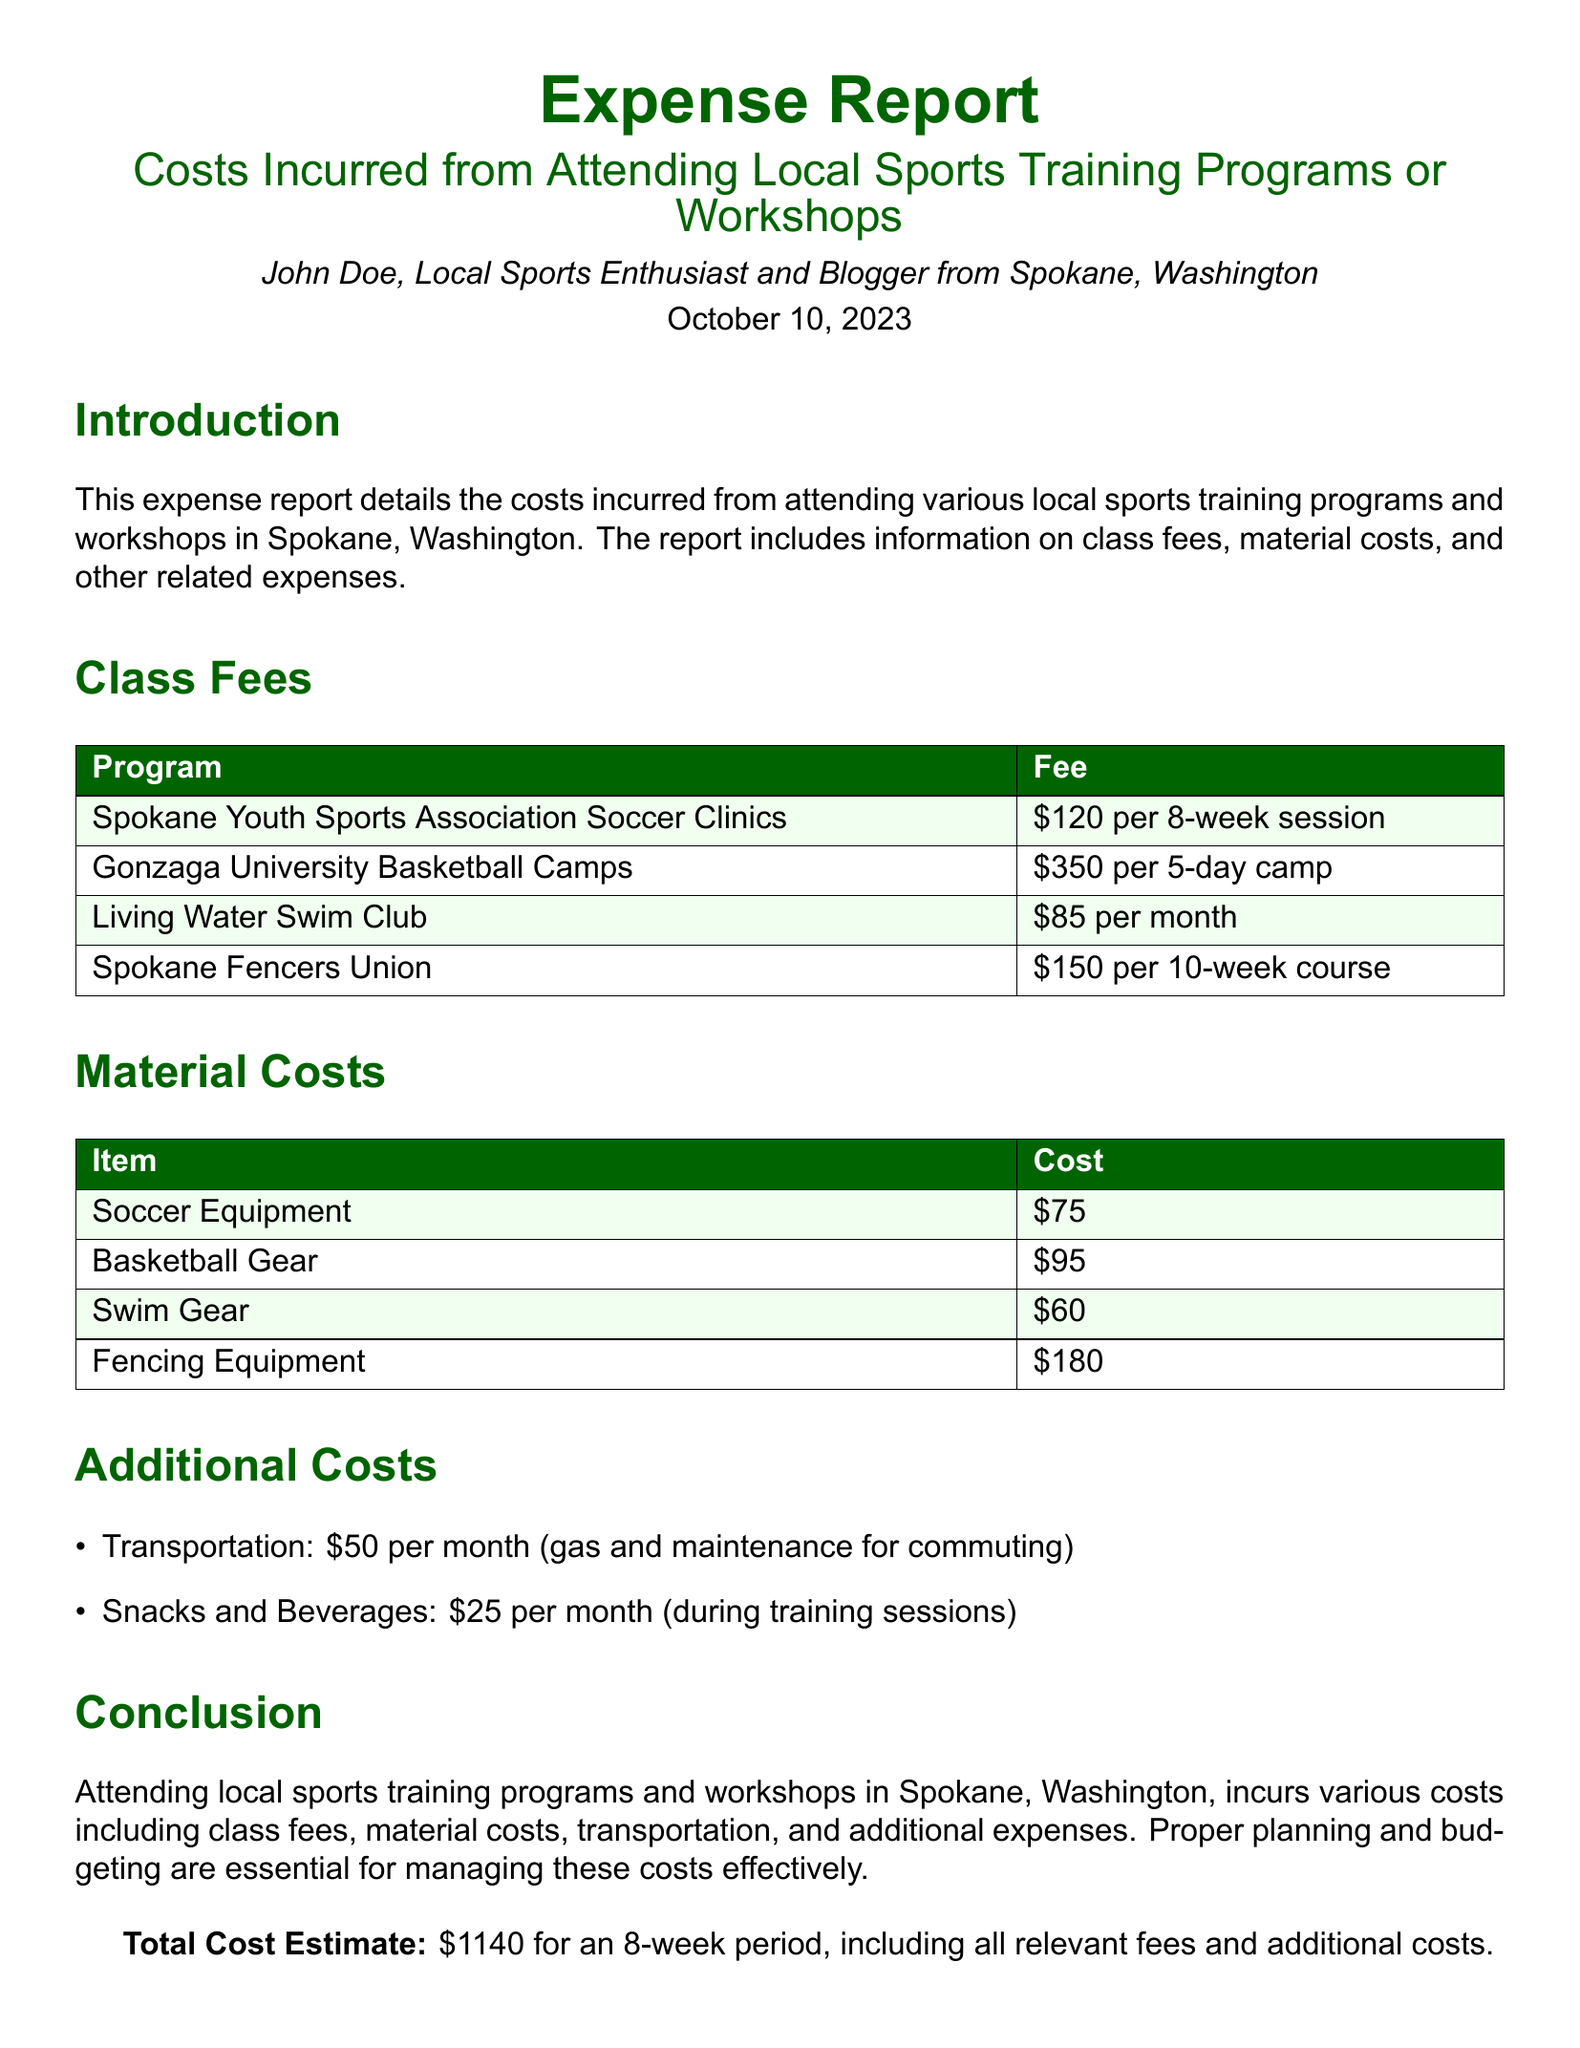what is the total cost estimate? The total cost estimate is mentioned in the conclusion of the report as \$1140 for an 8-week period.
Answer: \$1140 how much is the class fee for Gonzaga University Basketball Camps? The class fee for Gonzaga University Basketball Camps is \$350 for a 5-day camp.
Answer: \$350 what is the cost of Fencing Equipment? The cost of Fencing Equipment is stated in the material costs section of the report.
Answer: \$180 how many weeks does the Spokane Youth Sports Association Soccer Clinics session last? The duration of the session for Spokane Youth Sports Association Soccer Clinics is specified in the class fees section as 8 weeks.
Answer: 8 weeks what is the monthly transportation cost mentioned in the report? The report includes a monthly transportation cost for commuting, which is stated under additional costs.
Answer: \$50 which program has the highest class fee? The program with the highest class fee is identified in the class fees section of the report.
Answer: Gonzaga University Basketball Camps how much does the Living Water Swim Club charge per month? The monthly fee for Living Water Swim Club is mentioned in the class fees section of the report.
Answer: \$85 what additional cost is related to snacks and beverages? The additional cost for snacks and beverages is specified in the additional costs section.
Answer: \$25 how many weeks is the Spokane Fencers Union course? The length of the Spokane Fencers Union course is given in the class fees section of the report.
Answer: 10 weeks 